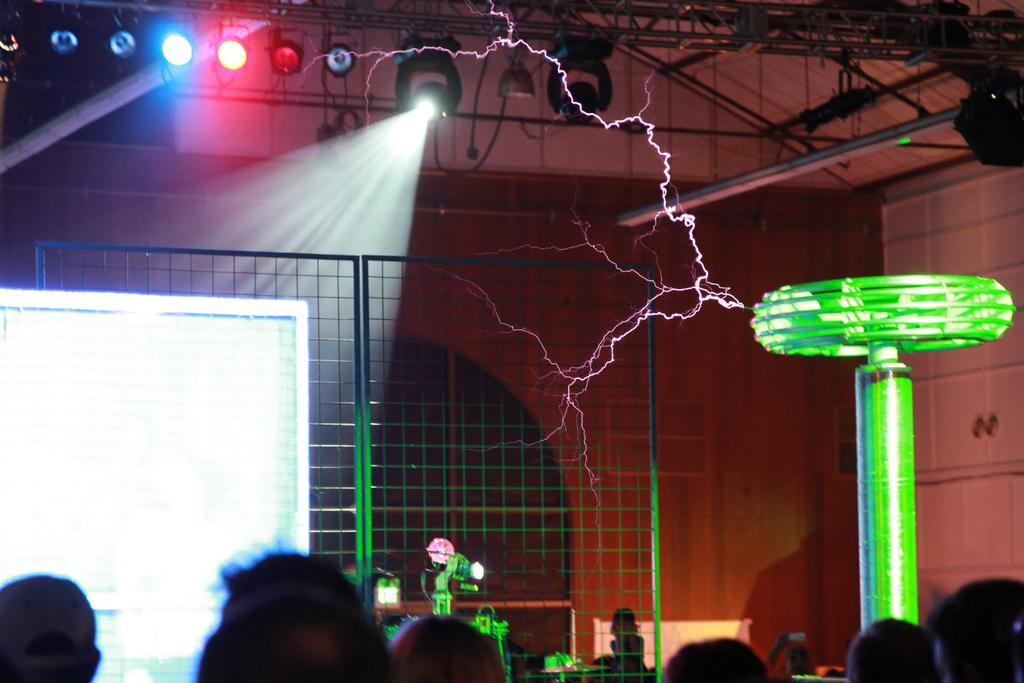Who or what can be seen in the image? There are people in the image. What can be seen illuminating the scene? There are lights in the image. What type of structure is present in the image? There is a grille in the image. What surface is visible in the image? There is a board in the image. What other objects can be seen in the image? There are other objects in the image. What is visible at the top of the image? There are metal rods visible at the top of the image. What is present in the background of the image? There is a wall in the background of the image. Are there any plants growing on the metal rods in the image? There are no plants visible on the metal rods in the image. What type of plastic material can be seen in the image? There is no plastic material present in the image. 